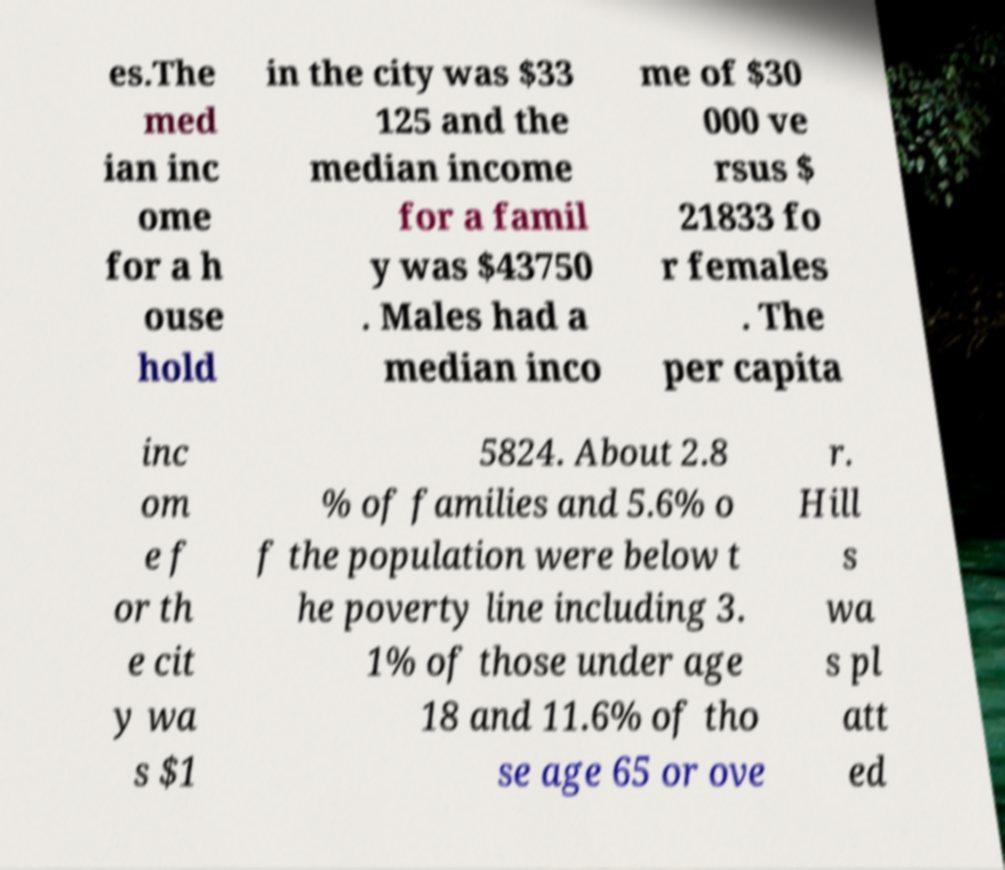Could you extract and type out the text from this image? es.The med ian inc ome for a h ouse hold in the city was $33 125 and the median income for a famil y was $43750 . Males had a median inco me of $30 000 ve rsus $ 21833 fo r females . The per capita inc om e f or th e cit y wa s $1 5824. About 2.8 % of families and 5.6% o f the population were below t he poverty line including 3. 1% of those under age 18 and 11.6% of tho se age 65 or ove r. Hill s wa s pl att ed 